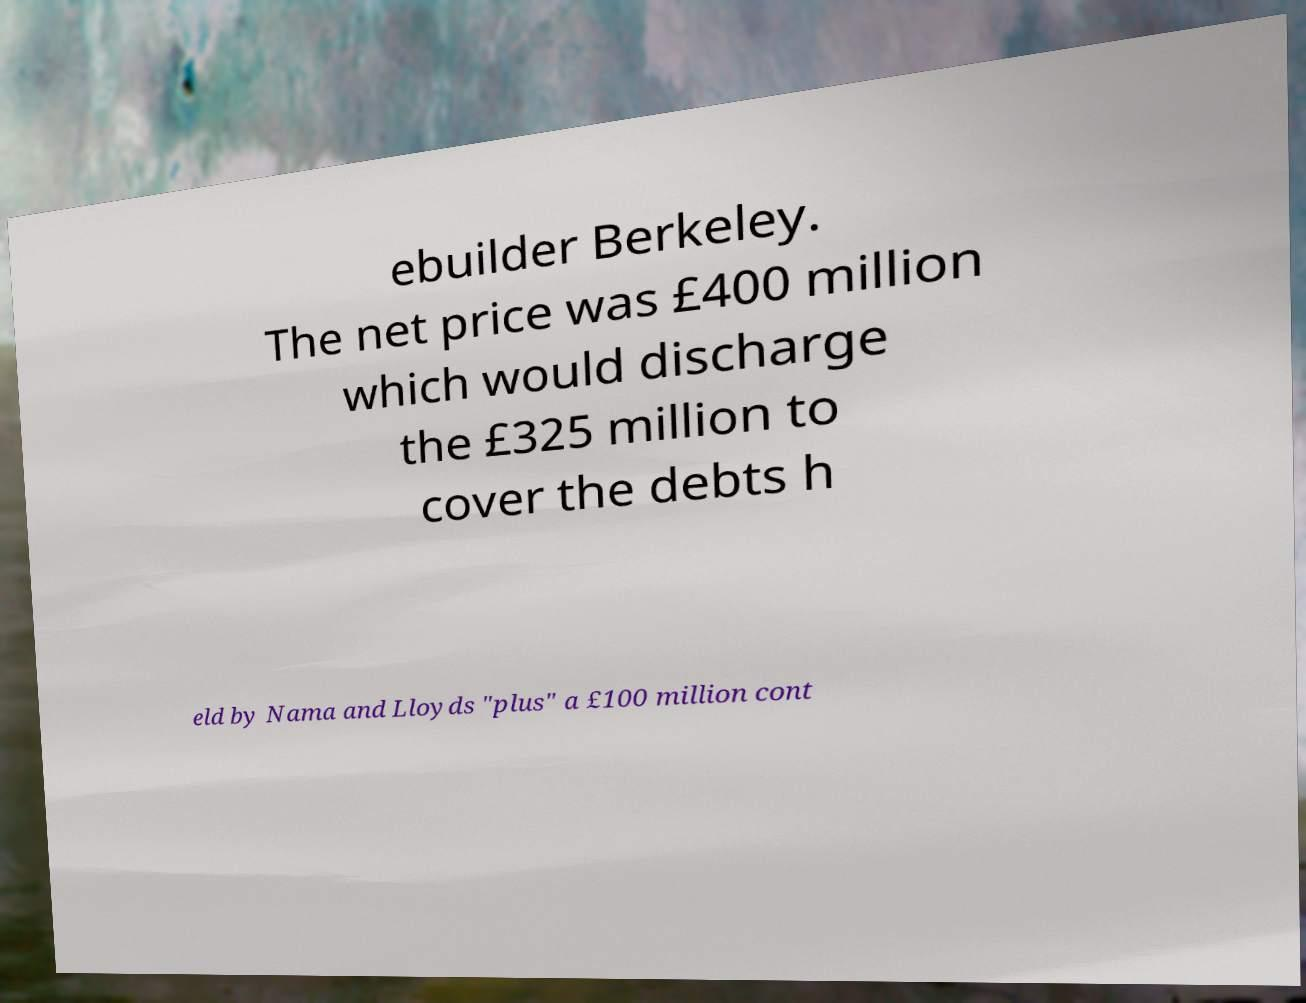Please read and relay the text visible in this image. What does it say? ebuilder Berkeley. The net price was £400 million which would discharge the £325 million to cover the debts h eld by Nama and Lloyds "plus" a £100 million cont 